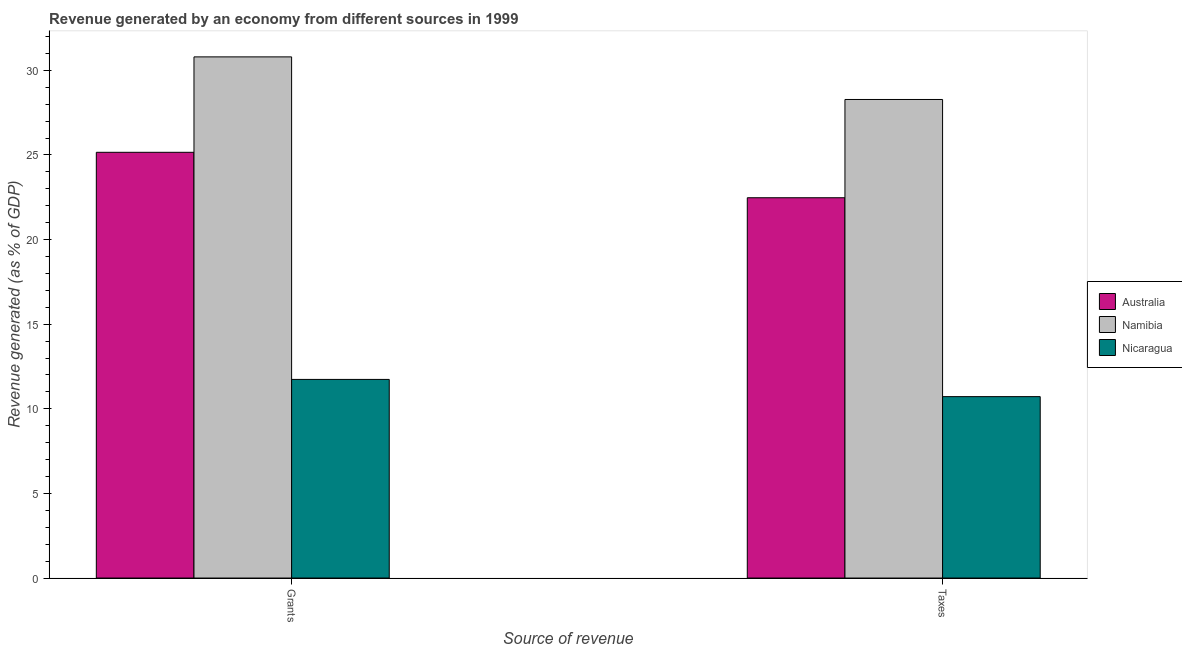How many different coloured bars are there?
Offer a very short reply. 3. How many bars are there on the 1st tick from the left?
Offer a very short reply. 3. How many bars are there on the 1st tick from the right?
Your response must be concise. 3. What is the label of the 2nd group of bars from the left?
Your response must be concise. Taxes. What is the revenue generated by taxes in Australia?
Offer a very short reply. 22.47. Across all countries, what is the maximum revenue generated by taxes?
Your answer should be compact. 28.28. Across all countries, what is the minimum revenue generated by grants?
Provide a succinct answer. 11.74. In which country was the revenue generated by grants maximum?
Ensure brevity in your answer.  Namibia. In which country was the revenue generated by taxes minimum?
Your response must be concise. Nicaragua. What is the total revenue generated by grants in the graph?
Offer a very short reply. 67.69. What is the difference between the revenue generated by taxes in Namibia and that in Nicaragua?
Your answer should be very brief. 17.56. What is the difference between the revenue generated by taxes in Namibia and the revenue generated by grants in Nicaragua?
Make the answer very short. 16.54. What is the average revenue generated by taxes per country?
Your answer should be very brief. 20.49. What is the difference between the revenue generated by taxes and revenue generated by grants in Namibia?
Give a very brief answer. -2.52. What is the ratio of the revenue generated by grants in Nicaragua to that in Australia?
Offer a very short reply. 0.47. In how many countries, is the revenue generated by taxes greater than the average revenue generated by taxes taken over all countries?
Make the answer very short. 2. What does the 3rd bar from the left in Grants represents?
Offer a terse response. Nicaragua. How many bars are there?
Your response must be concise. 6. Are all the bars in the graph horizontal?
Keep it short and to the point. No. How many countries are there in the graph?
Provide a short and direct response. 3. Does the graph contain any zero values?
Your response must be concise. No. How many legend labels are there?
Offer a very short reply. 3. How are the legend labels stacked?
Offer a terse response. Vertical. What is the title of the graph?
Provide a short and direct response. Revenue generated by an economy from different sources in 1999. What is the label or title of the X-axis?
Your answer should be compact. Source of revenue. What is the label or title of the Y-axis?
Give a very brief answer. Revenue generated (as % of GDP). What is the Revenue generated (as % of GDP) of Australia in Grants?
Keep it short and to the point. 25.16. What is the Revenue generated (as % of GDP) of Namibia in Grants?
Keep it short and to the point. 30.79. What is the Revenue generated (as % of GDP) of Nicaragua in Grants?
Your answer should be very brief. 11.74. What is the Revenue generated (as % of GDP) in Australia in Taxes?
Provide a short and direct response. 22.47. What is the Revenue generated (as % of GDP) in Namibia in Taxes?
Your answer should be very brief. 28.28. What is the Revenue generated (as % of GDP) of Nicaragua in Taxes?
Keep it short and to the point. 10.72. Across all Source of revenue, what is the maximum Revenue generated (as % of GDP) of Australia?
Make the answer very short. 25.16. Across all Source of revenue, what is the maximum Revenue generated (as % of GDP) of Namibia?
Ensure brevity in your answer.  30.79. Across all Source of revenue, what is the maximum Revenue generated (as % of GDP) of Nicaragua?
Ensure brevity in your answer.  11.74. Across all Source of revenue, what is the minimum Revenue generated (as % of GDP) of Australia?
Your answer should be very brief. 22.47. Across all Source of revenue, what is the minimum Revenue generated (as % of GDP) of Namibia?
Make the answer very short. 28.28. Across all Source of revenue, what is the minimum Revenue generated (as % of GDP) of Nicaragua?
Your response must be concise. 10.72. What is the total Revenue generated (as % of GDP) in Australia in the graph?
Give a very brief answer. 47.63. What is the total Revenue generated (as % of GDP) in Namibia in the graph?
Ensure brevity in your answer.  59.07. What is the total Revenue generated (as % of GDP) of Nicaragua in the graph?
Provide a succinct answer. 22.46. What is the difference between the Revenue generated (as % of GDP) of Australia in Grants and that in Taxes?
Provide a succinct answer. 2.68. What is the difference between the Revenue generated (as % of GDP) of Namibia in Grants and that in Taxes?
Provide a succinct answer. 2.52. What is the difference between the Revenue generated (as % of GDP) of Nicaragua in Grants and that in Taxes?
Your answer should be very brief. 1.02. What is the difference between the Revenue generated (as % of GDP) in Australia in Grants and the Revenue generated (as % of GDP) in Namibia in Taxes?
Provide a succinct answer. -3.12. What is the difference between the Revenue generated (as % of GDP) in Australia in Grants and the Revenue generated (as % of GDP) in Nicaragua in Taxes?
Provide a succinct answer. 14.44. What is the difference between the Revenue generated (as % of GDP) in Namibia in Grants and the Revenue generated (as % of GDP) in Nicaragua in Taxes?
Provide a short and direct response. 20.08. What is the average Revenue generated (as % of GDP) of Australia per Source of revenue?
Your answer should be compact. 23.81. What is the average Revenue generated (as % of GDP) of Namibia per Source of revenue?
Your answer should be very brief. 29.54. What is the average Revenue generated (as % of GDP) in Nicaragua per Source of revenue?
Keep it short and to the point. 11.23. What is the difference between the Revenue generated (as % of GDP) of Australia and Revenue generated (as % of GDP) of Namibia in Grants?
Give a very brief answer. -5.64. What is the difference between the Revenue generated (as % of GDP) in Australia and Revenue generated (as % of GDP) in Nicaragua in Grants?
Your response must be concise. 13.42. What is the difference between the Revenue generated (as % of GDP) in Namibia and Revenue generated (as % of GDP) in Nicaragua in Grants?
Your response must be concise. 19.06. What is the difference between the Revenue generated (as % of GDP) of Australia and Revenue generated (as % of GDP) of Namibia in Taxes?
Provide a succinct answer. -5.81. What is the difference between the Revenue generated (as % of GDP) in Australia and Revenue generated (as % of GDP) in Nicaragua in Taxes?
Your response must be concise. 11.75. What is the difference between the Revenue generated (as % of GDP) in Namibia and Revenue generated (as % of GDP) in Nicaragua in Taxes?
Ensure brevity in your answer.  17.56. What is the ratio of the Revenue generated (as % of GDP) in Australia in Grants to that in Taxes?
Your answer should be compact. 1.12. What is the ratio of the Revenue generated (as % of GDP) in Namibia in Grants to that in Taxes?
Give a very brief answer. 1.09. What is the ratio of the Revenue generated (as % of GDP) of Nicaragua in Grants to that in Taxes?
Keep it short and to the point. 1.09. What is the difference between the highest and the second highest Revenue generated (as % of GDP) of Australia?
Your answer should be very brief. 2.68. What is the difference between the highest and the second highest Revenue generated (as % of GDP) in Namibia?
Give a very brief answer. 2.52. What is the difference between the highest and the second highest Revenue generated (as % of GDP) of Nicaragua?
Provide a short and direct response. 1.02. What is the difference between the highest and the lowest Revenue generated (as % of GDP) of Australia?
Provide a succinct answer. 2.68. What is the difference between the highest and the lowest Revenue generated (as % of GDP) in Namibia?
Give a very brief answer. 2.52. What is the difference between the highest and the lowest Revenue generated (as % of GDP) of Nicaragua?
Give a very brief answer. 1.02. 